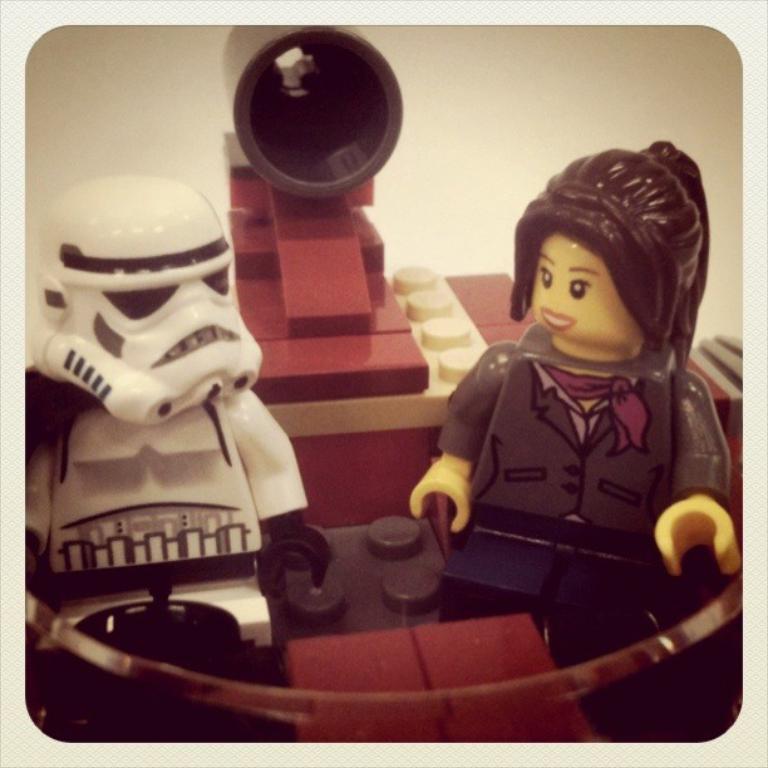Describe this image in one or two sentences. In this picture we can see toys and there is a white background. 